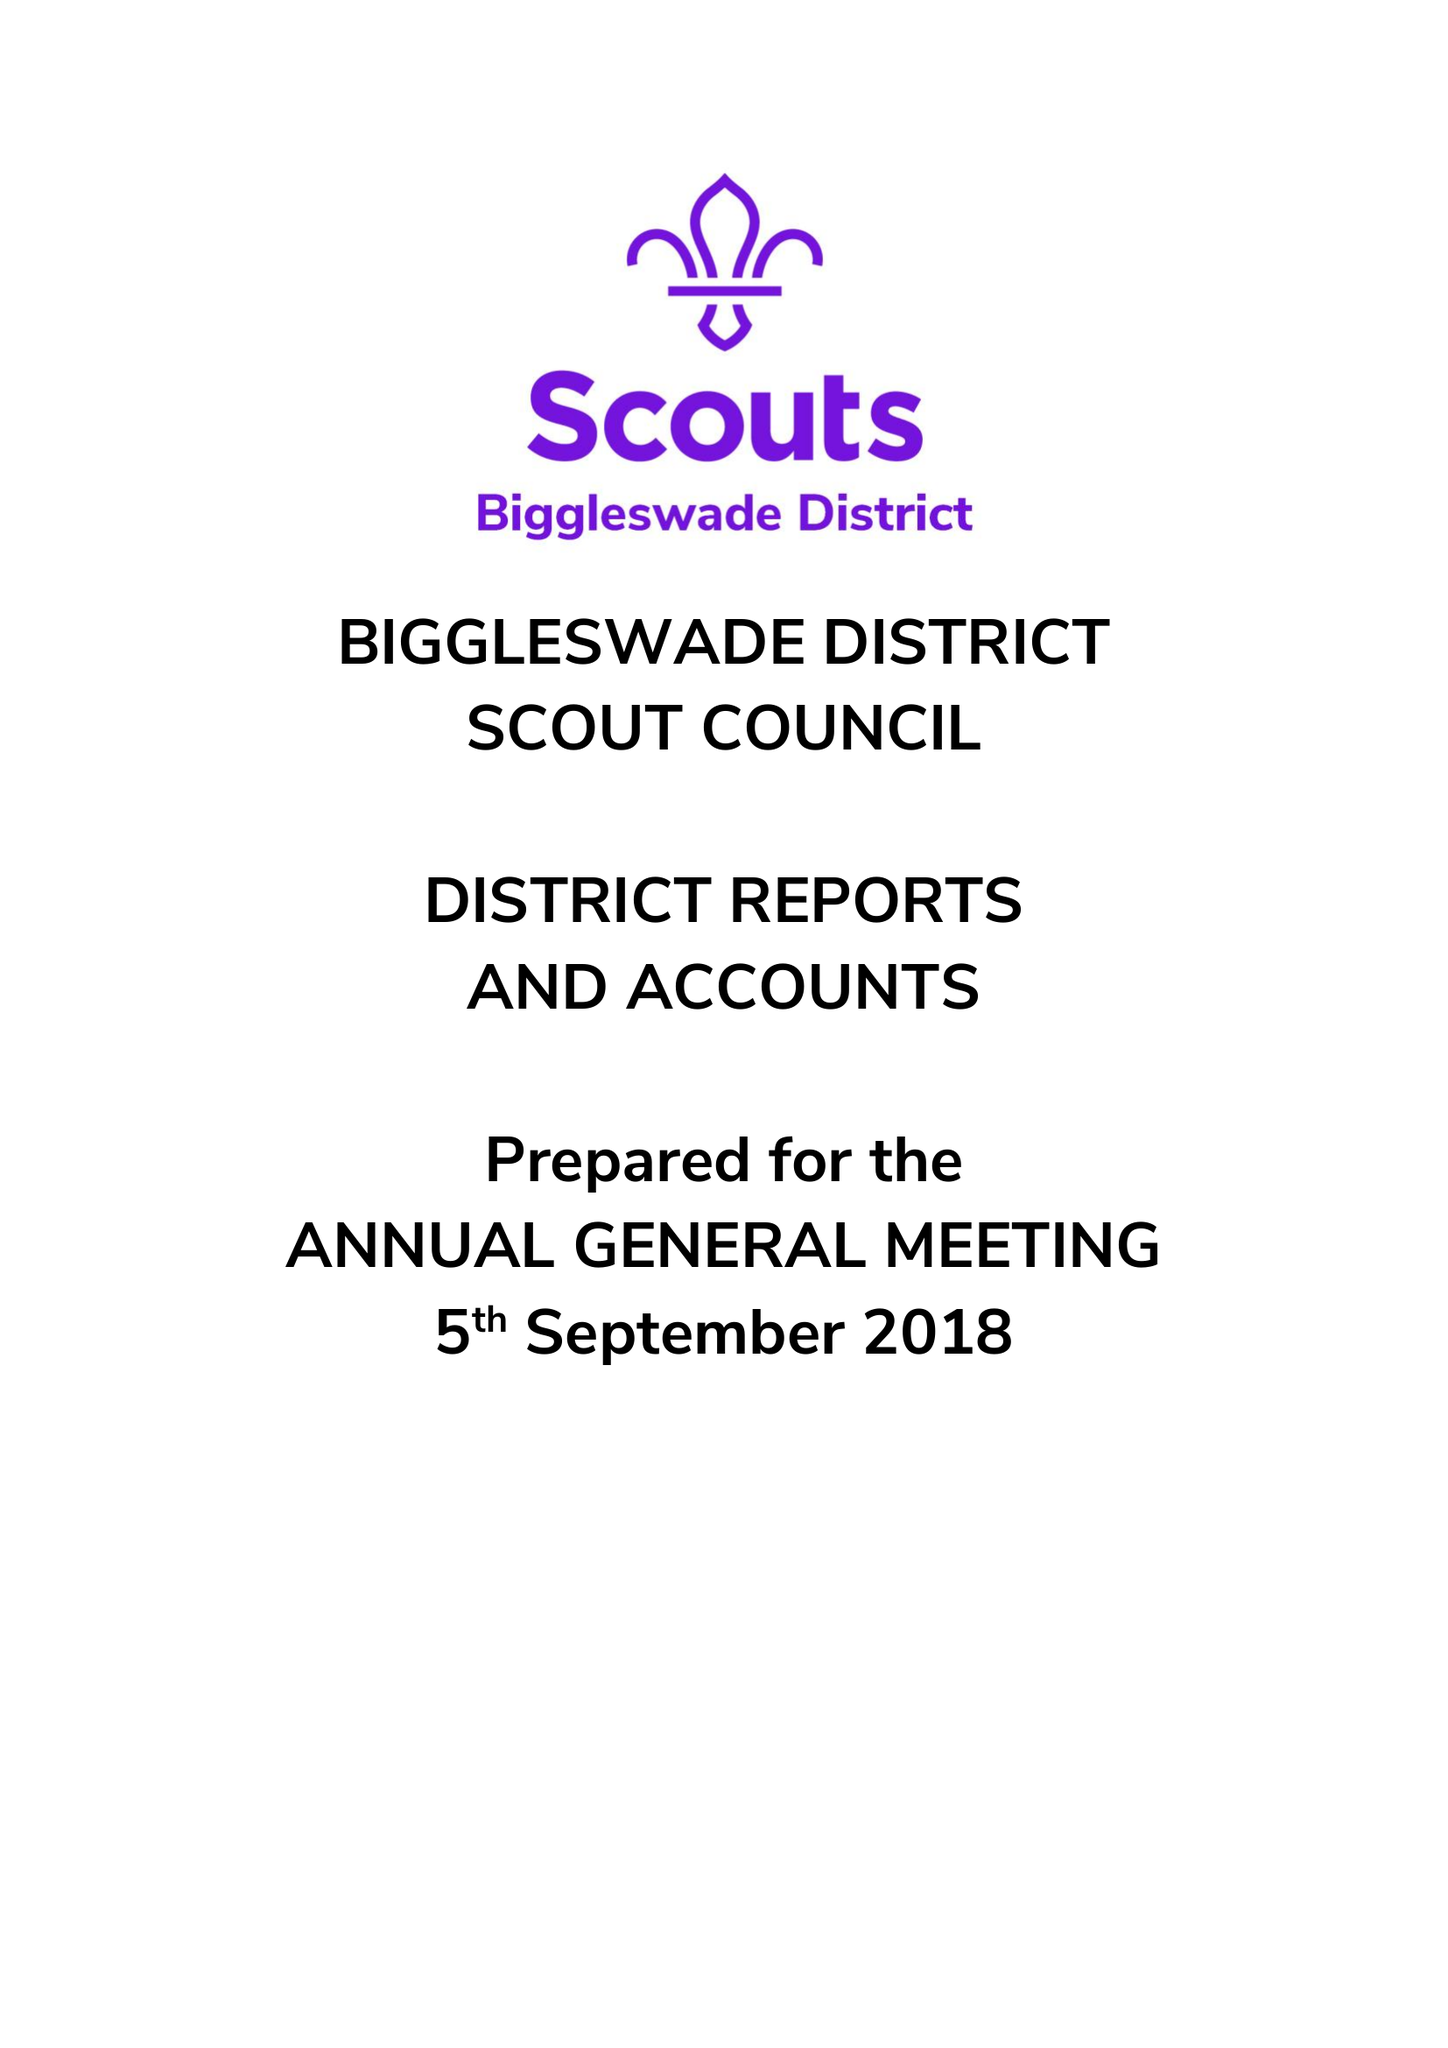What is the value for the charity_name?
Answer the question using a single word or phrase. Biggleswade District Scout Council 